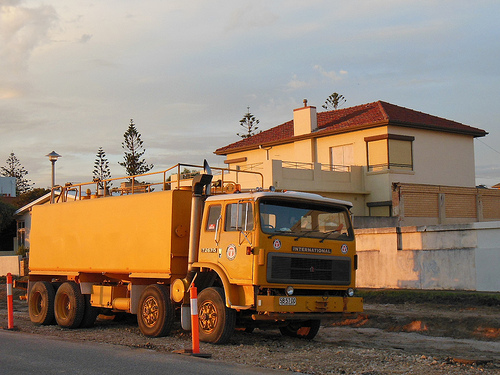Please provide a description for the region specified [0.5, 0.51, 0.72, 0.61]. The front window of a yellow truck is seen here, offering a view into the vehicle's interior, though it seems unoccupied. 